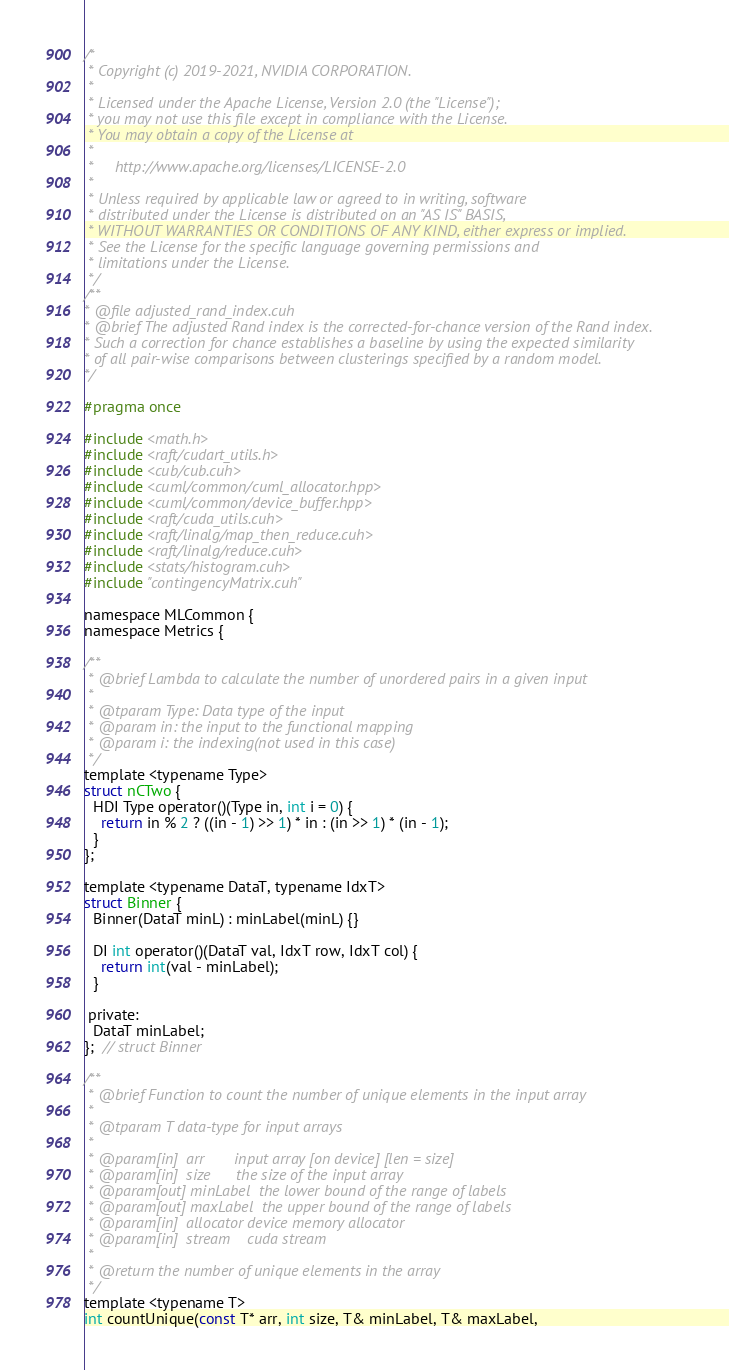<code> <loc_0><loc_0><loc_500><loc_500><_Cuda_>/*
 * Copyright (c) 2019-2021, NVIDIA CORPORATION.
 *
 * Licensed under the Apache License, Version 2.0 (the "License");
 * you may not use this file except in compliance with the License.
 * You may obtain a copy of the License at
 *
 *     http://www.apache.org/licenses/LICENSE-2.0
 *
 * Unless required by applicable law or agreed to in writing, software
 * distributed under the License is distributed on an "AS IS" BASIS,
 * WITHOUT WARRANTIES OR CONDITIONS OF ANY KIND, either express or implied.
 * See the License for the specific language governing permissions and
 * limitations under the License.
 */
/**
* @file adjusted_rand_index.cuh
* @brief The adjusted Rand index is the corrected-for-chance version of the Rand index.
* Such a correction for chance establishes a baseline by using the expected similarity
* of all pair-wise comparisons between clusterings specified by a random model.
*/

#pragma once

#include <math.h>
#include <raft/cudart_utils.h>
#include <cub/cub.cuh>
#include <cuml/common/cuml_allocator.hpp>
#include <cuml/common/device_buffer.hpp>
#include <raft/cuda_utils.cuh>
#include <raft/linalg/map_then_reduce.cuh>
#include <raft/linalg/reduce.cuh>
#include <stats/histogram.cuh>
#include "contingencyMatrix.cuh"

namespace MLCommon {
namespace Metrics {

/**
 * @brief Lambda to calculate the number of unordered pairs in a given input
 *
 * @tparam Type: Data type of the input
 * @param in: the input to the functional mapping
 * @param i: the indexing(not used in this case)
 */
template <typename Type>
struct nCTwo {
  HDI Type operator()(Type in, int i = 0) {
    return in % 2 ? ((in - 1) >> 1) * in : (in >> 1) * (in - 1);
  }
};

template <typename DataT, typename IdxT>
struct Binner {
  Binner(DataT minL) : minLabel(minL) {}

  DI int operator()(DataT val, IdxT row, IdxT col) {
    return int(val - minLabel);
  }

 private:
  DataT minLabel;
};  // struct Binner

/**
 * @brief Function to count the number of unique elements in the input array
 *
 * @tparam T data-type for input arrays
 *
 * @param[in]  arr       input array [on device] [len = size]
 * @param[in]  size      the size of the input array
 * @param[out] minLabel  the lower bound of the range of labels
 * @param[out] maxLabel  the upper bound of the range of labels
 * @param[in]  allocator device memory allocator
 * @param[in]  stream    cuda stream
 *
 * @return the number of unique elements in the array
 */
template <typename T>
int countUnique(const T* arr, int size, T& minLabel, T& maxLabel,</code> 